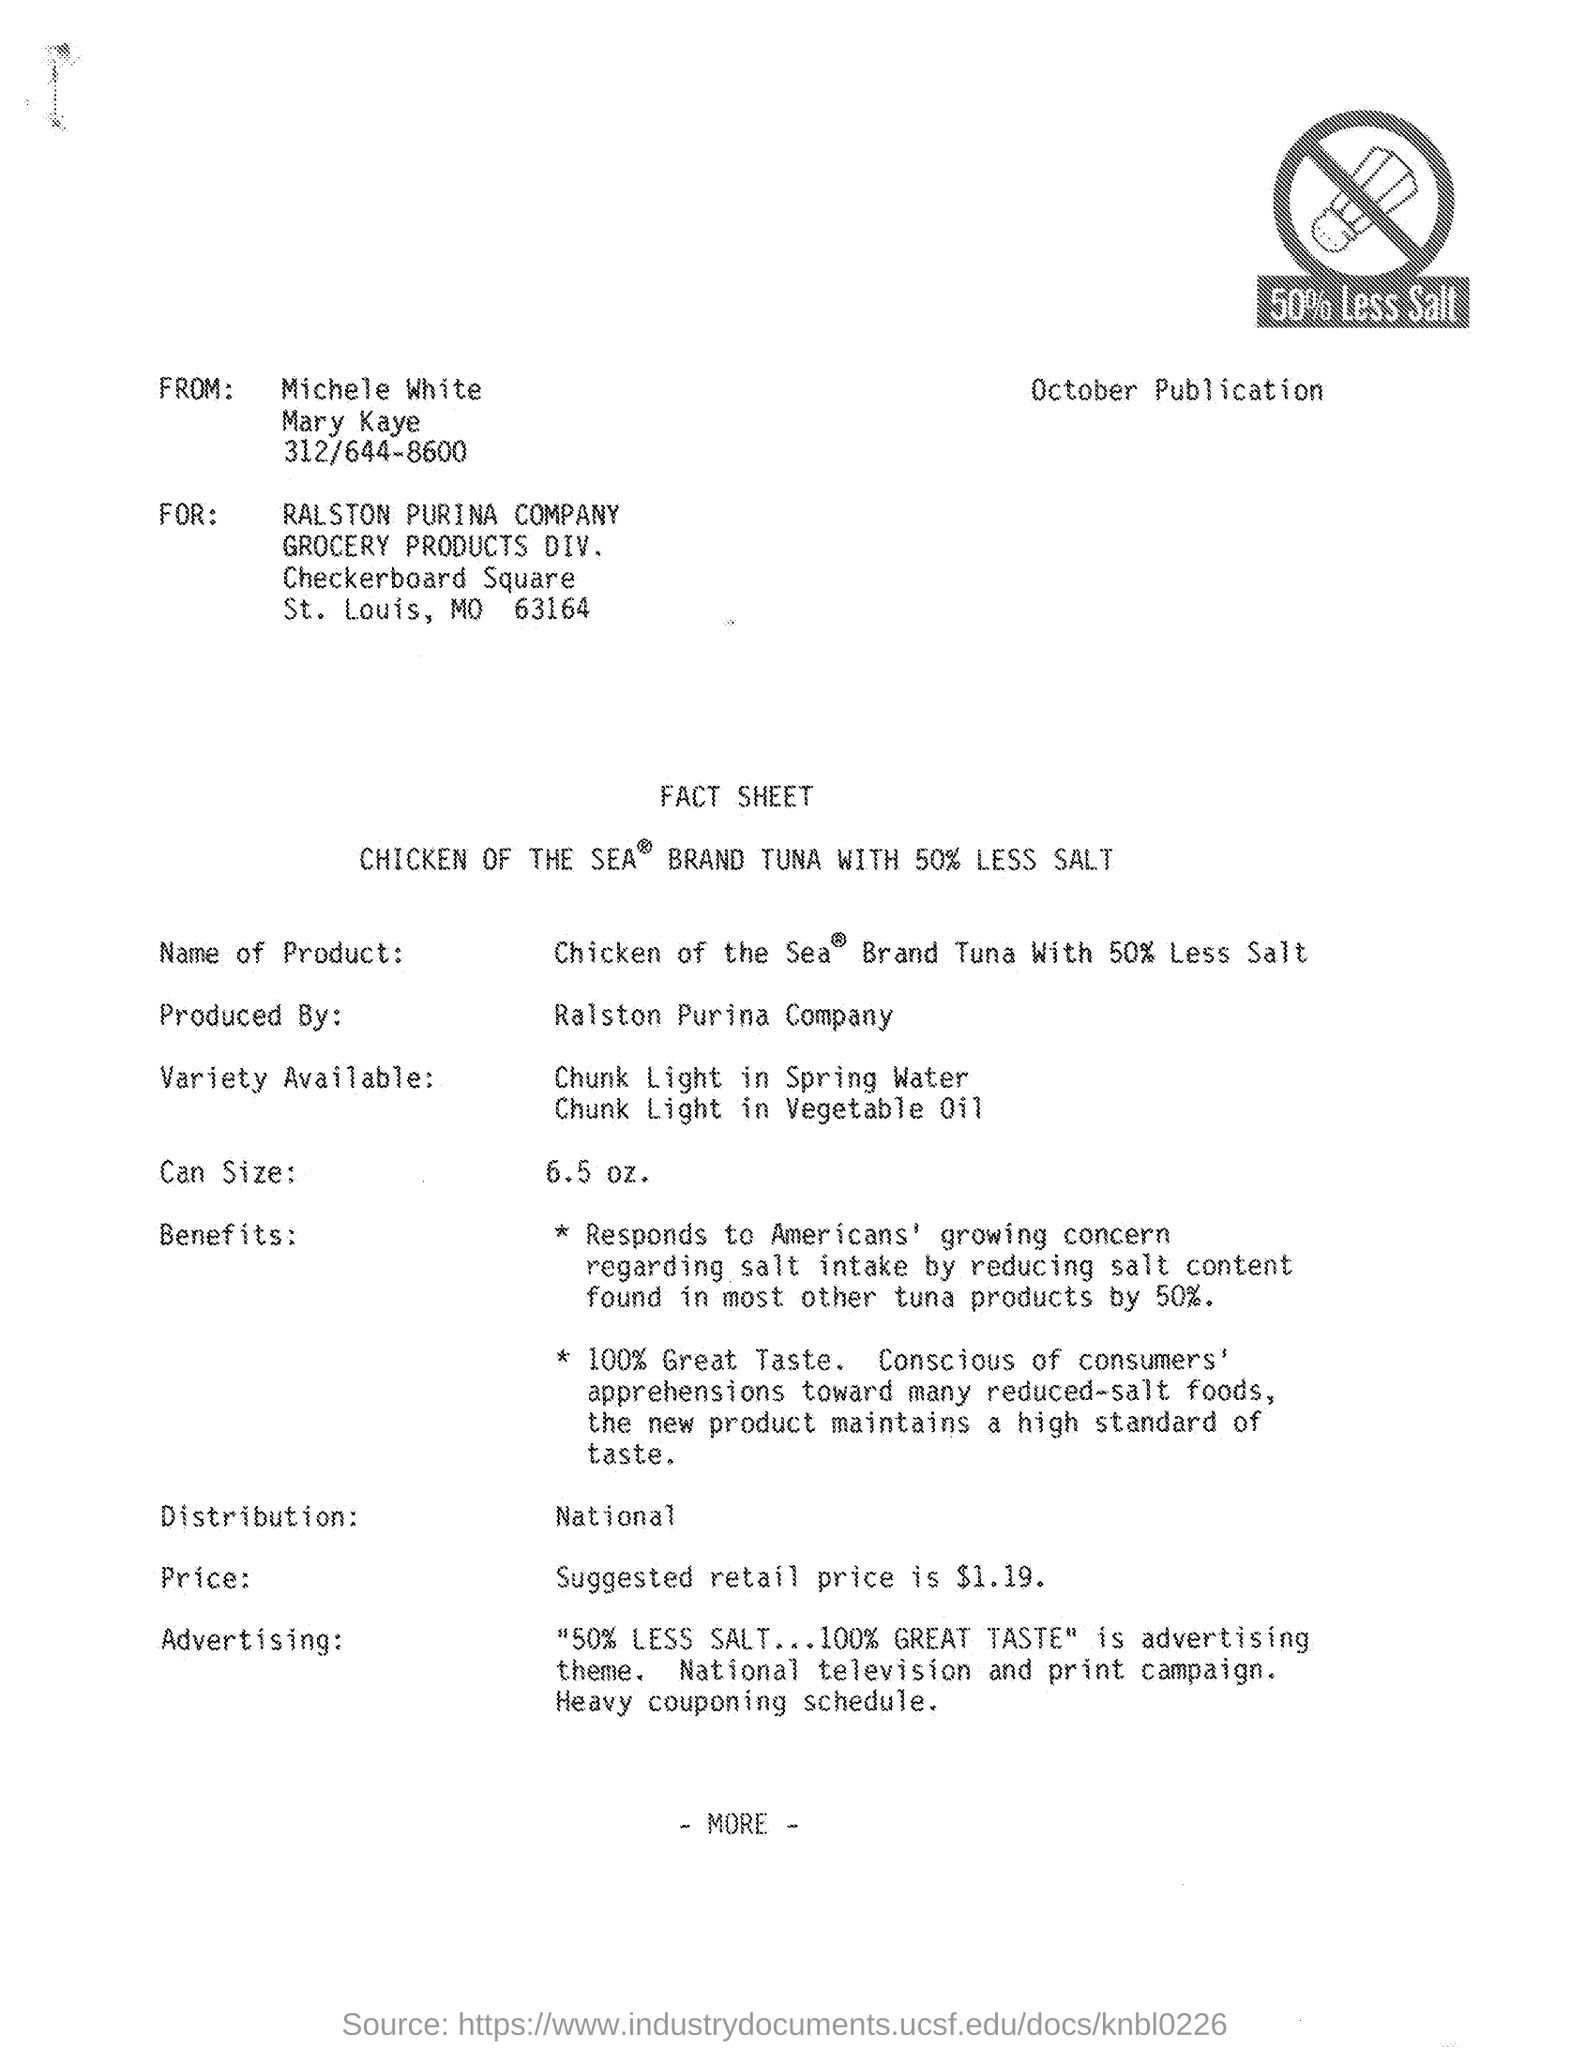what is the can size mentioned in the given fact sheet ?
 6.5 oz 